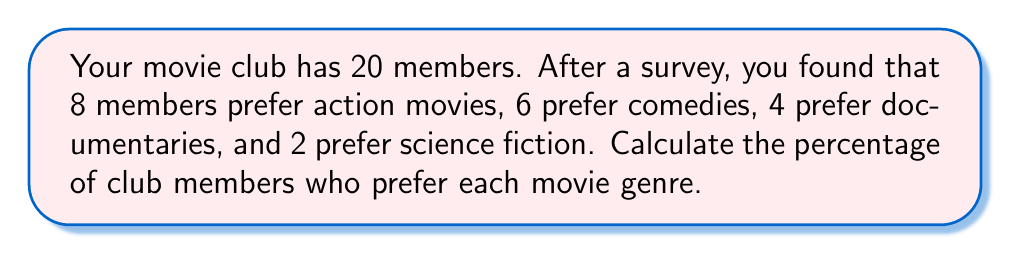Help me with this question. To calculate the percentage of club members who prefer each movie genre, we need to follow these steps:

1. Identify the total number of club members: 20

2. Count the number of members preferring each genre:
   - Action: 8
   - Comedy: 6
   - Documentary: 4
   - Science Fiction: 2

3. Calculate the percentage for each genre using the formula:
   $$ \text{Percentage} = \frac{\text{Number of members preferring the genre}}{\text{Total number of members}} \times 100\% $$

   For Action movies:
   $$ \text{Percentage} = \frac{8}{20} \times 100\% = 40\% $$

   For Comedies:
   $$ \text{Percentage} = \frac{6}{20} \times 100\% = 30\% $$

   For Documentaries:
   $$ \text{Percentage} = \frac{4}{20} \times 100\% = 20\% $$

   For Science Fiction:
   $$ \text{Percentage} = \frac{2}{20} \times 100\% = 10\% $$

4. Verify that the percentages sum up to 100%:
   $$ 40\% + 30\% + 20\% + 10\% = 100\% $$
Answer: Action: 40%
Comedy: 30%
Documentary: 20%
Science Fiction: 10% 